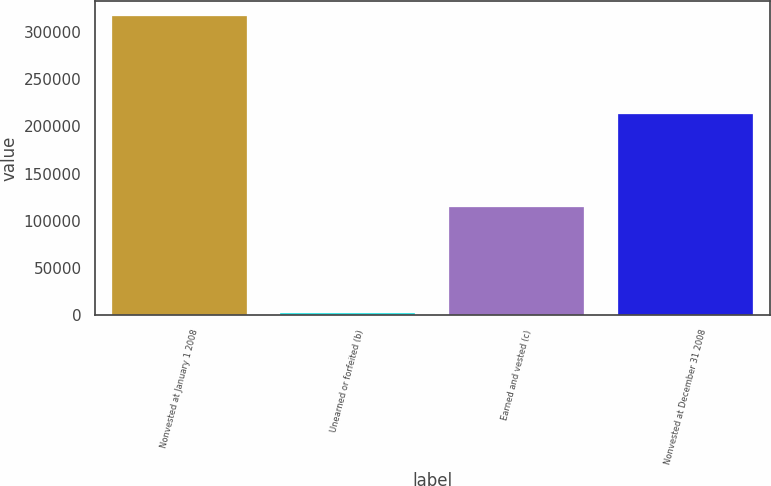<chart> <loc_0><loc_0><loc_500><loc_500><bar_chart><fcel>Nonvested at January 1 2008<fcel>Unearned or forfeited (b)<fcel>Earned and vested (c)<fcel>Nonvested at December 31 2008<nl><fcel>316768<fcel>2163<fcel>114286<fcel>213683<nl></chart> 